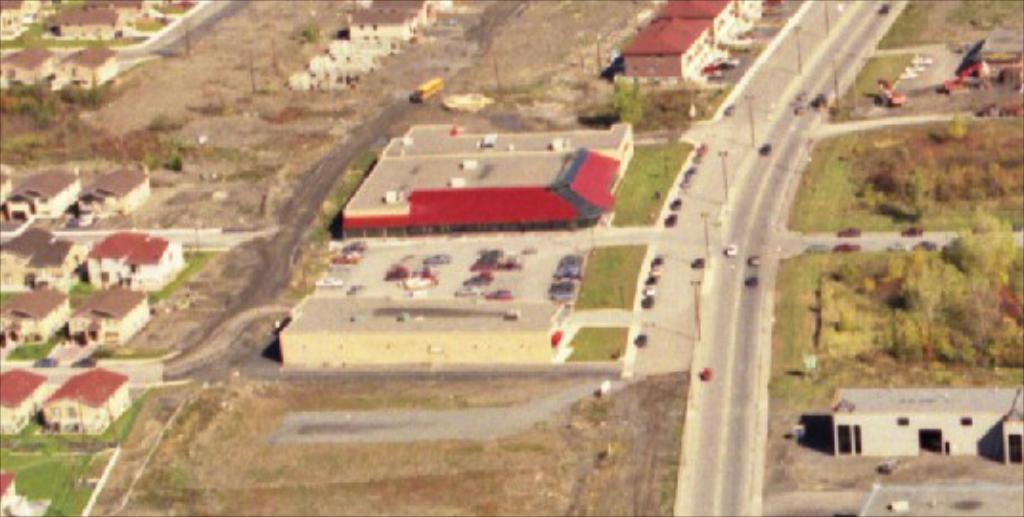What type of structures can be seen in the image? There are buildings in the image. What natural elements are present in the image? There are trees and grass visible in the image. What man-made objects can be seen in the image? There are poles and cars visible in the image. What type of surface can be seen in the image? There are roads in the image. Can you tell me how many stalks of celery are in the image? There is no celery present in the image. What suggestion is being made in the image? The image does not contain any suggestions; it is a visual representation of buildings, trees, poles, cars, roads, and grass. 